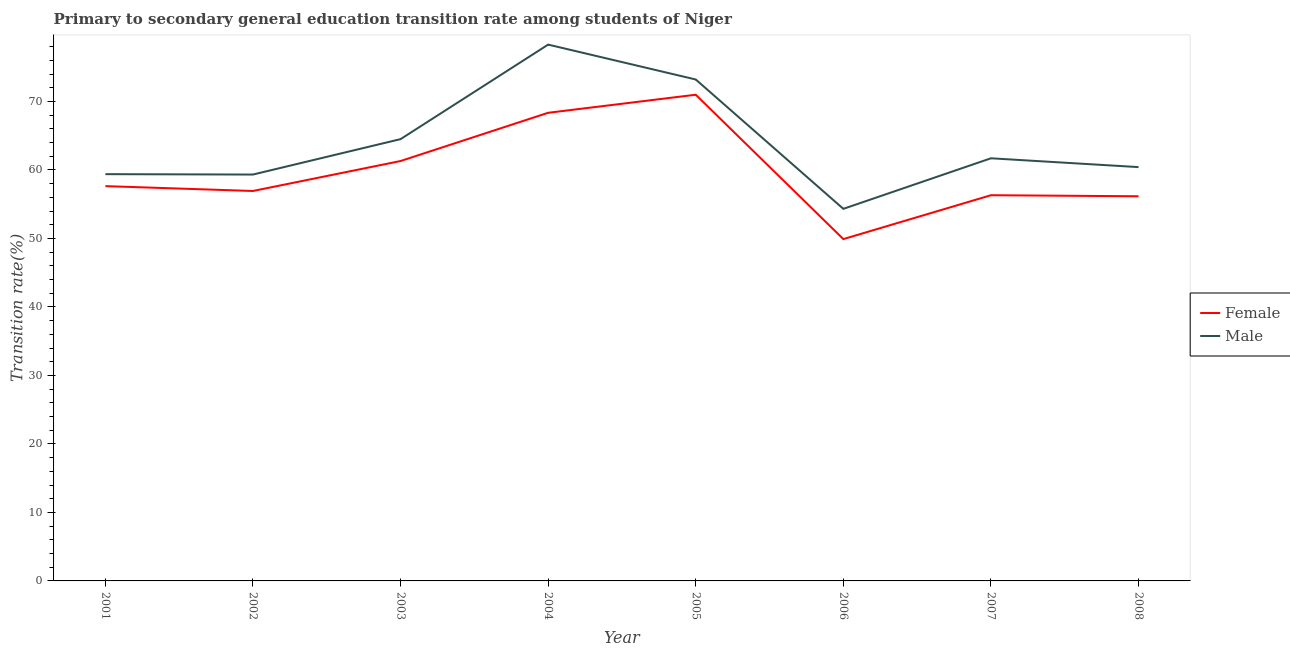How many different coloured lines are there?
Offer a terse response. 2. Is the number of lines equal to the number of legend labels?
Provide a succinct answer. Yes. What is the transition rate among male students in 2008?
Offer a terse response. 60.42. Across all years, what is the maximum transition rate among female students?
Offer a very short reply. 70.99. Across all years, what is the minimum transition rate among female students?
Your answer should be compact. 49.91. In which year was the transition rate among female students minimum?
Keep it short and to the point. 2006. What is the total transition rate among female students in the graph?
Keep it short and to the point. 477.6. What is the difference between the transition rate among male students in 2003 and that in 2007?
Keep it short and to the point. 2.8. What is the difference between the transition rate among male students in 2005 and the transition rate among female students in 2004?
Your answer should be very brief. 4.86. What is the average transition rate among male students per year?
Offer a terse response. 63.9. In the year 2004, what is the difference between the transition rate among male students and transition rate among female students?
Make the answer very short. 9.96. What is the ratio of the transition rate among female students in 2002 to that in 2004?
Offer a terse response. 0.83. What is the difference between the highest and the second highest transition rate among female students?
Make the answer very short. 2.64. What is the difference between the highest and the lowest transition rate among female students?
Ensure brevity in your answer.  21.08. In how many years, is the transition rate among female students greater than the average transition rate among female students taken over all years?
Give a very brief answer. 3. Is the sum of the transition rate among female students in 2001 and 2008 greater than the maximum transition rate among male students across all years?
Provide a succinct answer. Yes. Is the transition rate among female students strictly greater than the transition rate among male students over the years?
Provide a succinct answer. No. How many years are there in the graph?
Your answer should be very brief. 8. Does the graph contain any zero values?
Provide a succinct answer. No. Where does the legend appear in the graph?
Provide a short and direct response. Center right. How are the legend labels stacked?
Keep it short and to the point. Vertical. What is the title of the graph?
Give a very brief answer. Primary to secondary general education transition rate among students of Niger. Does "Research and Development" appear as one of the legend labels in the graph?
Make the answer very short. No. What is the label or title of the X-axis?
Offer a very short reply. Year. What is the label or title of the Y-axis?
Your answer should be compact. Transition rate(%). What is the Transition rate(%) in Female in 2001?
Your response must be concise. 57.64. What is the Transition rate(%) in Male in 2001?
Ensure brevity in your answer.  59.39. What is the Transition rate(%) in Female in 2002?
Ensure brevity in your answer.  56.93. What is the Transition rate(%) in Male in 2002?
Keep it short and to the point. 59.33. What is the Transition rate(%) in Female in 2003?
Your answer should be very brief. 61.31. What is the Transition rate(%) in Male in 2003?
Offer a very short reply. 64.5. What is the Transition rate(%) of Female in 2004?
Your answer should be compact. 68.35. What is the Transition rate(%) of Male in 2004?
Make the answer very short. 78.3. What is the Transition rate(%) in Female in 2005?
Give a very brief answer. 70.99. What is the Transition rate(%) in Male in 2005?
Give a very brief answer. 73.21. What is the Transition rate(%) in Female in 2006?
Provide a succinct answer. 49.91. What is the Transition rate(%) in Male in 2006?
Offer a terse response. 54.33. What is the Transition rate(%) of Female in 2007?
Give a very brief answer. 56.31. What is the Transition rate(%) of Male in 2007?
Make the answer very short. 61.71. What is the Transition rate(%) in Female in 2008?
Your response must be concise. 56.16. What is the Transition rate(%) of Male in 2008?
Your answer should be very brief. 60.42. Across all years, what is the maximum Transition rate(%) in Female?
Your answer should be compact. 70.99. Across all years, what is the maximum Transition rate(%) in Male?
Keep it short and to the point. 78.3. Across all years, what is the minimum Transition rate(%) in Female?
Make the answer very short. 49.91. Across all years, what is the minimum Transition rate(%) of Male?
Make the answer very short. 54.33. What is the total Transition rate(%) of Female in the graph?
Keep it short and to the point. 477.6. What is the total Transition rate(%) of Male in the graph?
Give a very brief answer. 511.19. What is the difference between the Transition rate(%) of Female in 2001 and that in 2002?
Offer a very short reply. 0.71. What is the difference between the Transition rate(%) of Male in 2001 and that in 2002?
Keep it short and to the point. 0.06. What is the difference between the Transition rate(%) of Female in 2001 and that in 2003?
Your answer should be very brief. -3.66. What is the difference between the Transition rate(%) of Male in 2001 and that in 2003?
Give a very brief answer. -5.11. What is the difference between the Transition rate(%) in Female in 2001 and that in 2004?
Your response must be concise. -10.71. What is the difference between the Transition rate(%) of Male in 2001 and that in 2004?
Provide a succinct answer. -18.92. What is the difference between the Transition rate(%) of Female in 2001 and that in 2005?
Your response must be concise. -13.34. What is the difference between the Transition rate(%) of Male in 2001 and that in 2005?
Ensure brevity in your answer.  -13.82. What is the difference between the Transition rate(%) in Female in 2001 and that in 2006?
Offer a terse response. 7.73. What is the difference between the Transition rate(%) of Male in 2001 and that in 2006?
Ensure brevity in your answer.  5.06. What is the difference between the Transition rate(%) in Female in 2001 and that in 2007?
Your answer should be very brief. 1.33. What is the difference between the Transition rate(%) of Male in 2001 and that in 2007?
Provide a succinct answer. -2.32. What is the difference between the Transition rate(%) of Female in 2001 and that in 2008?
Give a very brief answer. 1.48. What is the difference between the Transition rate(%) in Male in 2001 and that in 2008?
Give a very brief answer. -1.03. What is the difference between the Transition rate(%) in Female in 2002 and that in 2003?
Your answer should be compact. -4.37. What is the difference between the Transition rate(%) in Male in 2002 and that in 2003?
Ensure brevity in your answer.  -5.17. What is the difference between the Transition rate(%) in Female in 2002 and that in 2004?
Provide a succinct answer. -11.42. What is the difference between the Transition rate(%) of Male in 2002 and that in 2004?
Ensure brevity in your answer.  -18.97. What is the difference between the Transition rate(%) in Female in 2002 and that in 2005?
Give a very brief answer. -14.05. What is the difference between the Transition rate(%) of Male in 2002 and that in 2005?
Provide a succinct answer. -13.88. What is the difference between the Transition rate(%) in Female in 2002 and that in 2006?
Your answer should be compact. 7.03. What is the difference between the Transition rate(%) in Male in 2002 and that in 2006?
Keep it short and to the point. 5.01. What is the difference between the Transition rate(%) in Female in 2002 and that in 2007?
Keep it short and to the point. 0.62. What is the difference between the Transition rate(%) in Male in 2002 and that in 2007?
Give a very brief answer. -2.37. What is the difference between the Transition rate(%) in Female in 2002 and that in 2008?
Give a very brief answer. 0.77. What is the difference between the Transition rate(%) of Male in 2002 and that in 2008?
Make the answer very short. -1.09. What is the difference between the Transition rate(%) of Female in 2003 and that in 2004?
Offer a very short reply. -7.04. What is the difference between the Transition rate(%) of Male in 2003 and that in 2004?
Ensure brevity in your answer.  -13.8. What is the difference between the Transition rate(%) of Female in 2003 and that in 2005?
Offer a terse response. -9.68. What is the difference between the Transition rate(%) in Male in 2003 and that in 2005?
Your response must be concise. -8.71. What is the difference between the Transition rate(%) of Female in 2003 and that in 2006?
Provide a succinct answer. 11.4. What is the difference between the Transition rate(%) in Male in 2003 and that in 2006?
Keep it short and to the point. 10.18. What is the difference between the Transition rate(%) of Female in 2003 and that in 2007?
Keep it short and to the point. 4.99. What is the difference between the Transition rate(%) in Male in 2003 and that in 2007?
Offer a very short reply. 2.8. What is the difference between the Transition rate(%) of Female in 2003 and that in 2008?
Your answer should be compact. 5.15. What is the difference between the Transition rate(%) in Male in 2003 and that in 2008?
Your answer should be compact. 4.08. What is the difference between the Transition rate(%) of Female in 2004 and that in 2005?
Offer a very short reply. -2.64. What is the difference between the Transition rate(%) of Male in 2004 and that in 2005?
Offer a very short reply. 5.1. What is the difference between the Transition rate(%) in Female in 2004 and that in 2006?
Provide a short and direct response. 18.44. What is the difference between the Transition rate(%) of Male in 2004 and that in 2006?
Your answer should be compact. 23.98. What is the difference between the Transition rate(%) of Female in 2004 and that in 2007?
Provide a succinct answer. 12.04. What is the difference between the Transition rate(%) of Male in 2004 and that in 2007?
Make the answer very short. 16.6. What is the difference between the Transition rate(%) in Female in 2004 and that in 2008?
Ensure brevity in your answer.  12.19. What is the difference between the Transition rate(%) of Male in 2004 and that in 2008?
Make the answer very short. 17.89. What is the difference between the Transition rate(%) in Female in 2005 and that in 2006?
Make the answer very short. 21.08. What is the difference between the Transition rate(%) of Male in 2005 and that in 2006?
Provide a short and direct response. 18.88. What is the difference between the Transition rate(%) in Female in 2005 and that in 2007?
Your response must be concise. 14.67. What is the difference between the Transition rate(%) in Male in 2005 and that in 2007?
Give a very brief answer. 11.5. What is the difference between the Transition rate(%) in Female in 2005 and that in 2008?
Keep it short and to the point. 14.83. What is the difference between the Transition rate(%) of Male in 2005 and that in 2008?
Your answer should be very brief. 12.79. What is the difference between the Transition rate(%) in Female in 2006 and that in 2007?
Offer a very short reply. -6.41. What is the difference between the Transition rate(%) in Male in 2006 and that in 2007?
Offer a very short reply. -7.38. What is the difference between the Transition rate(%) of Female in 2006 and that in 2008?
Offer a terse response. -6.25. What is the difference between the Transition rate(%) in Male in 2006 and that in 2008?
Your response must be concise. -6.09. What is the difference between the Transition rate(%) of Female in 2007 and that in 2008?
Provide a short and direct response. 0.15. What is the difference between the Transition rate(%) of Male in 2007 and that in 2008?
Give a very brief answer. 1.29. What is the difference between the Transition rate(%) of Female in 2001 and the Transition rate(%) of Male in 2002?
Ensure brevity in your answer.  -1.69. What is the difference between the Transition rate(%) of Female in 2001 and the Transition rate(%) of Male in 2003?
Offer a very short reply. -6.86. What is the difference between the Transition rate(%) in Female in 2001 and the Transition rate(%) in Male in 2004?
Keep it short and to the point. -20.66. What is the difference between the Transition rate(%) in Female in 2001 and the Transition rate(%) in Male in 2005?
Give a very brief answer. -15.57. What is the difference between the Transition rate(%) of Female in 2001 and the Transition rate(%) of Male in 2006?
Offer a very short reply. 3.32. What is the difference between the Transition rate(%) in Female in 2001 and the Transition rate(%) in Male in 2007?
Provide a succinct answer. -4.06. What is the difference between the Transition rate(%) in Female in 2001 and the Transition rate(%) in Male in 2008?
Your answer should be compact. -2.78. What is the difference between the Transition rate(%) in Female in 2002 and the Transition rate(%) in Male in 2003?
Ensure brevity in your answer.  -7.57. What is the difference between the Transition rate(%) in Female in 2002 and the Transition rate(%) in Male in 2004?
Ensure brevity in your answer.  -21.37. What is the difference between the Transition rate(%) in Female in 2002 and the Transition rate(%) in Male in 2005?
Offer a terse response. -16.28. What is the difference between the Transition rate(%) in Female in 2002 and the Transition rate(%) in Male in 2006?
Your response must be concise. 2.61. What is the difference between the Transition rate(%) of Female in 2002 and the Transition rate(%) of Male in 2007?
Give a very brief answer. -4.77. What is the difference between the Transition rate(%) in Female in 2002 and the Transition rate(%) in Male in 2008?
Make the answer very short. -3.49. What is the difference between the Transition rate(%) of Female in 2003 and the Transition rate(%) of Male in 2004?
Provide a short and direct response. -17. What is the difference between the Transition rate(%) in Female in 2003 and the Transition rate(%) in Male in 2005?
Offer a very short reply. -11.9. What is the difference between the Transition rate(%) of Female in 2003 and the Transition rate(%) of Male in 2006?
Your answer should be very brief. 6.98. What is the difference between the Transition rate(%) of Female in 2003 and the Transition rate(%) of Male in 2007?
Provide a succinct answer. -0.4. What is the difference between the Transition rate(%) of Female in 2003 and the Transition rate(%) of Male in 2008?
Keep it short and to the point. 0.89. What is the difference between the Transition rate(%) in Female in 2004 and the Transition rate(%) in Male in 2005?
Give a very brief answer. -4.86. What is the difference between the Transition rate(%) of Female in 2004 and the Transition rate(%) of Male in 2006?
Your answer should be compact. 14.02. What is the difference between the Transition rate(%) of Female in 2004 and the Transition rate(%) of Male in 2007?
Give a very brief answer. 6.64. What is the difference between the Transition rate(%) in Female in 2004 and the Transition rate(%) in Male in 2008?
Provide a short and direct response. 7.93. What is the difference between the Transition rate(%) of Female in 2005 and the Transition rate(%) of Male in 2006?
Provide a succinct answer. 16.66. What is the difference between the Transition rate(%) of Female in 2005 and the Transition rate(%) of Male in 2007?
Make the answer very short. 9.28. What is the difference between the Transition rate(%) of Female in 2005 and the Transition rate(%) of Male in 2008?
Your answer should be compact. 10.57. What is the difference between the Transition rate(%) of Female in 2006 and the Transition rate(%) of Male in 2007?
Provide a short and direct response. -11.8. What is the difference between the Transition rate(%) in Female in 2006 and the Transition rate(%) in Male in 2008?
Offer a very short reply. -10.51. What is the difference between the Transition rate(%) of Female in 2007 and the Transition rate(%) of Male in 2008?
Keep it short and to the point. -4.1. What is the average Transition rate(%) of Female per year?
Provide a succinct answer. 59.7. What is the average Transition rate(%) in Male per year?
Ensure brevity in your answer.  63.9. In the year 2001, what is the difference between the Transition rate(%) of Female and Transition rate(%) of Male?
Provide a short and direct response. -1.75. In the year 2002, what is the difference between the Transition rate(%) of Female and Transition rate(%) of Male?
Keep it short and to the point. -2.4. In the year 2003, what is the difference between the Transition rate(%) in Female and Transition rate(%) in Male?
Provide a succinct answer. -3.2. In the year 2004, what is the difference between the Transition rate(%) of Female and Transition rate(%) of Male?
Provide a succinct answer. -9.96. In the year 2005, what is the difference between the Transition rate(%) in Female and Transition rate(%) in Male?
Provide a short and direct response. -2.22. In the year 2006, what is the difference between the Transition rate(%) in Female and Transition rate(%) in Male?
Offer a terse response. -4.42. In the year 2007, what is the difference between the Transition rate(%) in Female and Transition rate(%) in Male?
Keep it short and to the point. -5.39. In the year 2008, what is the difference between the Transition rate(%) of Female and Transition rate(%) of Male?
Offer a terse response. -4.26. What is the ratio of the Transition rate(%) in Female in 2001 to that in 2002?
Offer a very short reply. 1.01. What is the ratio of the Transition rate(%) of Female in 2001 to that in 2003?
Your answer should be very brief. 0.94. What is the ratio of the Transition rate(%) in Male in 2001 to that in 2003?
Give a very brief answer. 0.92. What is the ratio of the Transition rate(%) of Female in 2001 to that in 2004?
Your answer should be very brief. 0.84. What is the ratio of the Transition rate(%) of Male in 2001 to that in 2004?
Offer a very short reply. 0.76. What is the ratio of the Transition rate(%) in Female in 2001 to that in 2005?
Make the answer very short. 0.81. What is the ratio of the Transition rate(%) in Male in 2001 to that in 2005?
Provide a short and direct response. 0.81. What is the ratio of the Transition rate(%) of Female in 2001 to that in 2006?
Make the answer very short. 1.16. What is the ratio of the Transition rate(%) in Male in 2001 to that in 2006?
Provide a short and direct response. 1.09. What is the ratio of the Transition rate(%) of Female in 2001 to that in 2007?
Keep it short and to the point. 1.02. What is the ratio of the Transition rate(%) in Male in 2001 to that in 2007?
Your answer should be very brief. 0.96. What is the ratio of the Transition rate(%) in Female in 2001 to that in 2008?
Offer a very short reply. 1.03. What is the ratio of the Transition rate(%) of Male in 2001 to that in 2008?
Ensure brevity in your answer.  0.98. What is the ratio of the Transition rate(%) of Female in 2002 to that in 2003?
Provide a succinct answer. 0.93. What is the ratio of the Transition rate(%) in Male in 2002 to that in 2003?
Offer a terse response. 0.92. What is the ratio of the Transition rate(%) of Female in 2002 to that in 2004?
Offer a very short reply. 0.83. What is the ratio of the Transition rate(%) in Male in 2002 to that in 2004?
Your answer should be very brief. 0.76. What is the ratio of the Transition rate(%) of Female in 2002 to that in 2005?
Provide a short and direct response. 0.8. What is the ratio of the Transition rate(%) of Male in 2002 to that in 2005?
Offer a very short reply. 0.81. What is the ratio of the Transition rate(%) of Female in 2002 to that in 2006?
Make the answer very short. 1.14. What is the ratio of the Transition rate(%) of Male in 2002 to that in 2006?
Your answer should be compact. 1.09. What is the ratio of the Transition rate(%) of Female in 2002 to that in 2007?
Offer a terse response. 1.01. What is the ratio of the Transition rate(%) of Male in 2002 to that in 2007?
Keep it short and to the point. 0.96. What is the ratio of the Transition rate(%) of Female in 2002 to that in 2008?
Keep it short and to the point. 1.01. What is the ratio of the Transition rate(%) in Female in 2003 to that in 2004?
Offer a terse response. 0.9. What is the ratio of the Transition rate(%) of Male in 2003 to that in 2004?
Provide a succinct answer. 0.82. What is the ratio of the Transition rate(%) in Female in 2003 to that in 2005?
Provide a short and direct response. 0.86. What is the ratio of the Transition rate(%) of Male in 2003 to that in 2005?
Offer a terse response. 0.88. What is the ratio of the Transition rate(%) in Female in 2003 to that in 2006?
Ensure brevity in your answer.  1.23. What is the ratio of the Transition rate(%) of Male in 2003 to that in 2006?
Provide a succinct answer. 1.19. What is the ratio of the Transition rate(%) of Female in 2003 to that in 2007?
Ensure brevity in your answer.  1.09. What is the ratio of the Transition rate(%) in Male in 2003 to that in 2007?
Make the answer very short. 1.05. What is the ratio of the Transition rate(%) in Female in 2003 to that in 2008?
Offer a terse response. 1.09. What is the ratio of the Transition rate(%) in Male in 2003 to that in 2008?
Provide a succinct answer. 1.07. What is the ratio of the Transition rate(%) of Female in 2004 to that in 2005?
Offer a very short reply. 0.96. What is the ratio of the Transition rate(%) of Male in 2004 to that in 2005?
Give a very brief answer. 1.07. What is the ratio of the Transition rate(%) of Female in 2004 to that in 2006?
Provide a short and direct response. 1.37. What is the ratio of the Transition rate(%) of Male in 2004 to that in 2006?
Offer a very short reply. 1.44. What is the ratio of the Transition rate(%) of Female in 2004 to that in 2007?
Make the answer very short. 1.21. What is the ratio of the Transition rate(%) of Male in 2004 to that in 2007?
Your answer should be compact. 1.27. What is the ratio of the Transition rate(%) of Female in 2004 to that in 2008?
Make the answer very short. 1.22. What is the ratio of the Transition rate(%) in Male in 2004 to that in 2008?
Offer a very short reply. 1.3. What is the ratio of the Transition rate(%) in Female in 2005 to that in 2006?
Give a very brief answer. 1.42. What is the ratio of the Transition rate(%) of Male in 2005 to that in 2006?
Offer a terse response. 1.35. What is the ratio of the Transition rate(%) of Female in 2005 to that in 2007?
Offer a very short reply. 1.26. What is the ratio of the Transition rate(%) of Male in 2005 to that in 2007?
Provide a short and direct response. 1.19. What is the ratio of the Transition rate(%) in Female in 2005 to that in 2008?
Give a very brief answer. 1.26. What is the ratio of the Transition rate(%) in Male in 2005 to that in 2008?
Your answer should be compact. 1.21. What is the ratio of the Transition rate(%) of Female in 2006 to that in 2007?
Provide a succinct answer. 0.89. What is the ratio of the Transition rate(%) of Male in 2006 to that in 2007?
Your answer should be very brief. 0.88. What is the ratio of the Transition rate(%) of Female in 2006 to that in 2008?
Provide a short and direct response. 0.89. What is the ratio of the Transition rate(%) in Male in 2006 to that in 2008?
Keep it short and to the point. 0.9. What is the ratio of the Transition rate(%) of Female in 2007 to that in 2008?
Offer a very short reply. 1. What is the ratio of the Transition rate(%) of Male in 2007 to that in 2008?
Provide a short and direct response. 1.02. What is the difference between the highest and the second highest Transition rate(%) of Female?
Your answer should be very brief. 2.64. What is the difference between the highest and the second highest Transition rate(%) in Male?
Offer a terse response. 5.1. What is the difference between the highest and the lowest Transition rate(%) in Female?
Ensure brevity in your answer.  21.08. What is the difference between the highest and the lowest Transition rate(%) of Male?
Your answer should be very brief. 23.98. 